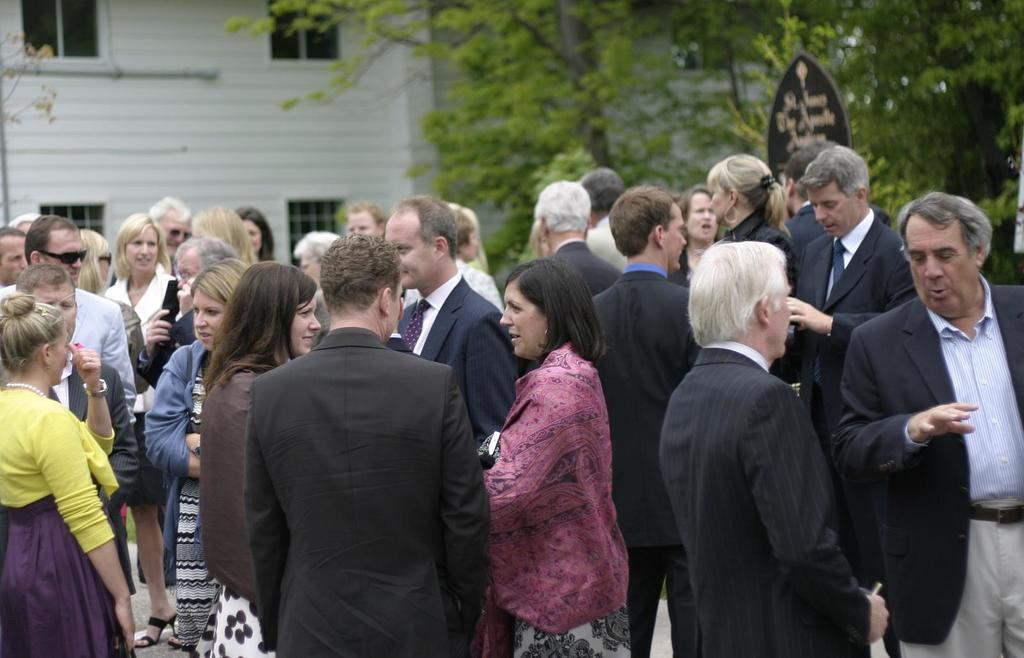How many people are in the group visible in the image? The number of people in the group is not specified, but there is a group of people in the image. Where is the group of people located in the image? The group of people is at the bottom of the image. What can be seen in the background of the image? There is a building and trees in the background of the image. What is the rate at which the moon is rising in the image? There is no moon visible in the image, so it is not possible to determine the rate at which it is rising. 